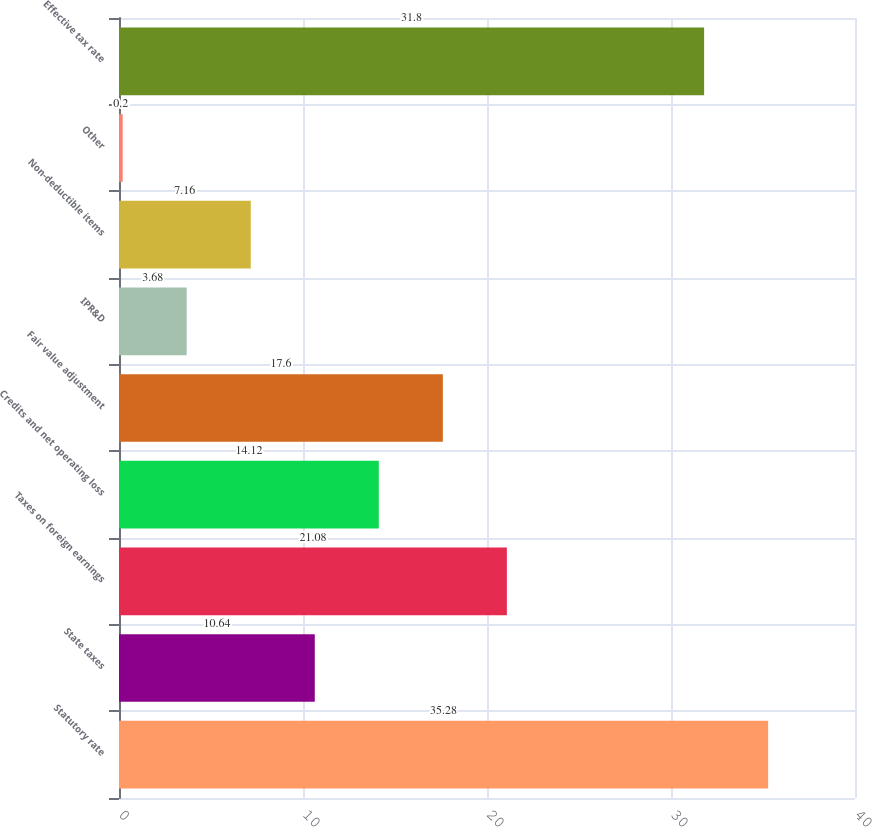Convert chart. <chart><loc_0><loc_0><loc_500><loc_500><bar_chart><fcel>Statutory rate<fcel>State taxes<fcel>Taxes on foreign earnings<fcel>Credits and net operating loss<fcel>Fair value adjustment<fcel>IPR&D<fcel>Non-deductible items<fcel>Other<fcel>Effective tax rate<nl><fcel>35.28<fcel>10.64<fcel>21.08<fcel>14.12<fcel>17.6<fcel>3.68<fcel>7.16<fcel>0.2<fcel>31.8<nl></chart> 